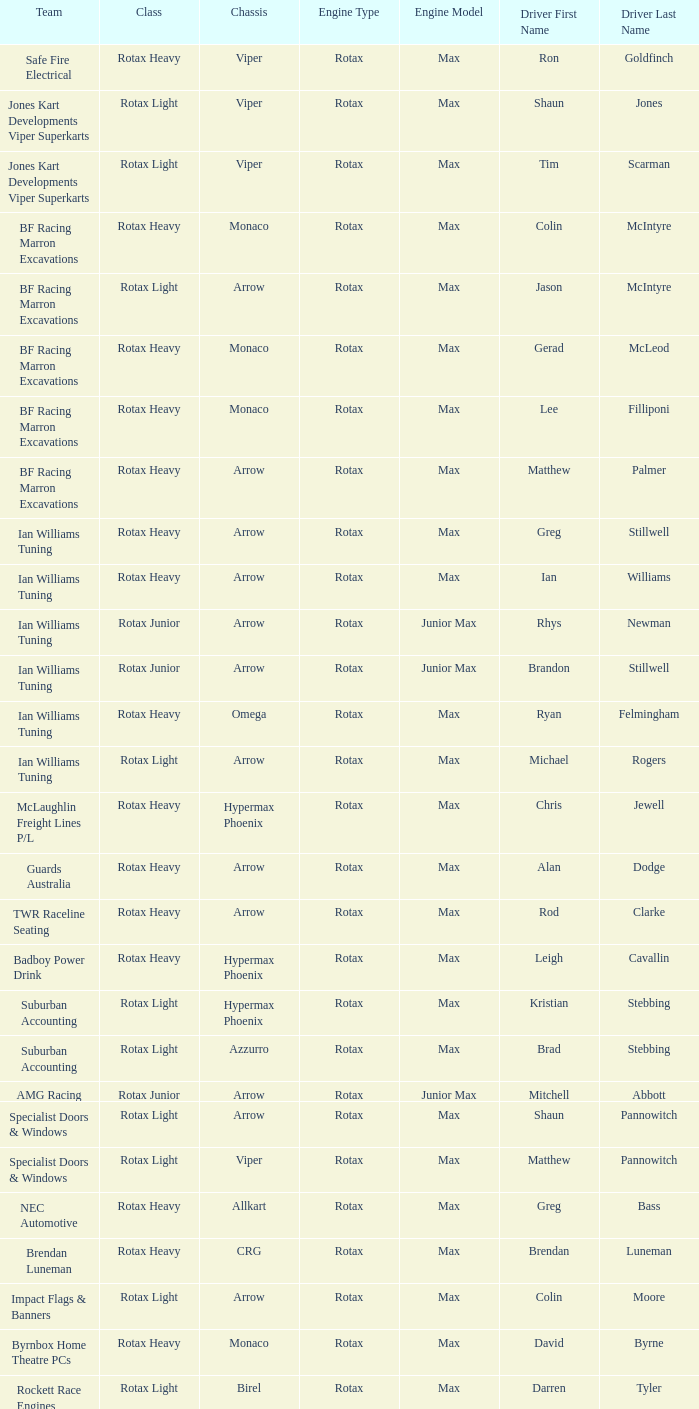Driver Shaun Jones with a viper as a chassis is in what class? Rotax Light. Would you mind parsing the complete table? {'header': ['Team', 'Class', 'Chassis', 'Engine Type', 'Engine Model', 'Driver First Name', 'Driver Last Name'], 'rows': [['Safe Fire Electrical', 'Rotax Heavy', 'Viper', 'Rotax', 'Max', 'Ron', 'Goldfinch'], ['Jones Kart Developments Viper Superkarts', 'Rotax Light', 'Viper', 'Rotax', 'Max', 'Shaun', 'Jones'], ['Jones Kart Developments Viper Superkarts', 'Rotax Light', 'Viper', 'Rotax', 'Max', 'Tim', 'Scarman'], ['BF Racing Marron Excavations', 'Rotax Heavy', 'Monaco', 'Rotax', 'Max', 'Colin', 'McIntyre'], ['BF Racing Marron Excavations', 'Rotax Light', 'Arrow', 'Rotax', 'Max', 'Jason', 'McIntyre'], ['BF Racing Marron Excavations', 'Rotax Heavy', 'Monaco', 'Rotax', 'Max', 'Gerad', 'McLeod'], ['BF Racing Marron Excavations', 'Rotax Heavy', 'Monaco', 'Rotax', 'Max', 'Lee', 'Filliponi'], ['BF Racing Marron Excavations', 'Rotax Heavy', 'Arrow', 'Rotax', 'Max', 'Matthew', 'Palmer'], ['Ian Williams Tuning', 'Rotax Heavy', 'Arrow', 'Rotax', 'Max', 'Greg', 'Stillwell'], ['Ian Williams Tuning', 'Rotax Heavy', 'Arrow', 'Rotax', 'Max', 'Ian', 'Williams'], ['Ian Williams Tuning', 'Rotax Junior', 'Arrow', 'Rotax', 'Junior Max', 'Rhys', 'Newman'], ['Ian Williams Tuning', 'Rotax Junior', 'Arrow', 'Rotax', 'Junior Max', 'Brandon', 'Stillwell'], ['Ian Williams Tuning', 'Rotax Heavy', 'Omega', 'Rotax', 'Max', 'Ryan', 'Felmingham'], ['Ian Williams Tuning', 'Rotax Light', 'Arrow', 'Rotax', 'Max', 'Michael', 'Rogers'], ['McLaughlin Freight Lines P/L', 'Rotax Heavy', 'Hypermax Phoenix', 'Rotax', 'Max', 'Chris', 'Jewell'], ['Guards Australia', 'Rotax Heavy', 'Arrow', 'Rotax', 'Max', 'Alan', 'Dodge'], ['TWR Raceline Seating', 'Rotax Heavy', 'Arrow', 'Rotax', 'Max', 'Rod', 'Clarke'], ['Badboy Power Drink', 'Rotax Heavy', 'Hypermax Phoenix', 'Rotax', 'Max', 'Leigh', 'Cavallin'], ['Suburban Accounting', 'Rotax Light', 'Hypermax Phoenix', 'Rotax', 'Max', 'Kristian', 'Stebbing'], ['Suburban Accounting', 'Rotax Light', 'Azzurro', 'Rotax', 'Max', 'Brad', 'Stebbing'], ['AMG Racing', 'Rotax Junior', 'Arrow', 'Rotax', 'Junior Max', 'Mitchell', 'Abbott'], ['Specialist Doors & Windows', 'Rotax Light', 'Arrow', 'Rotax', 'Max', 'Shaun', 'Pannowitch'], ['Specialist Doors & Windows', 'Rotax Light', 'Viper', 'Rotax', 'Max', 'Matthew', 'Pannowitch'], ['NEC Automotive', 'Rotax Heavy', 'Allkart', 'Rotax', 'Max', 'Greg', 'Bass'], ['Brendan Luneman', 'Rotax Heavy', 'CRG', 'Rotax', 'Max', 'Brendan', 'Luneman'], ['Impact Flags & Banners', 'Rotax Light', 'Arrow', 'Rotax', 'Max', 'Colin', 'Moore'], ['Byrnbox Home Theatre PCs', 'Rotax Heavy', 'Monaco', 'Rotax', 'Max', 'David', 'Byrne'], ['Rockett Race Engines', 'Rotax Light', 'Birel', 'Rotax', 'Max', 'Darren', 'Tyler'], ['Racecentre', 'Rotax Junior', 'Arrow', 'Rotax', 'Junior Max', 'David', 'Webster'], ['Racecentre', 'Rotax Light', 'Arrow', 'Rotax', 'Max', 'Peter', 'Strangis'], ['www.kartsportnews.com', 'Rotax Heavy', 'Hypermax Phoenix', 'Rotax', 'Max', 'Mark', 'Wicks'], ['Doug Savage', 'Rotax Light', 'Arrow', 'Rotax', 'Max', 'Doug', 'Savage'], ['Race Stickerz Toyota Material Handling', 'Rotax Heavy', 'Techno', 'Rotax', 'Max', 'Scott', 'Appledore'], ['Wild Digital', 'Rotax Junior', 'Hypermax Phoenix', 'Rotax', 'Junior Max', 'Sean', 'Whitfield'], ['John Bartlett', 'Rotax Heavy', 'Hypermax Phoenix', 'Rotax', 'Max', 'John', 'Bartlett']]} 